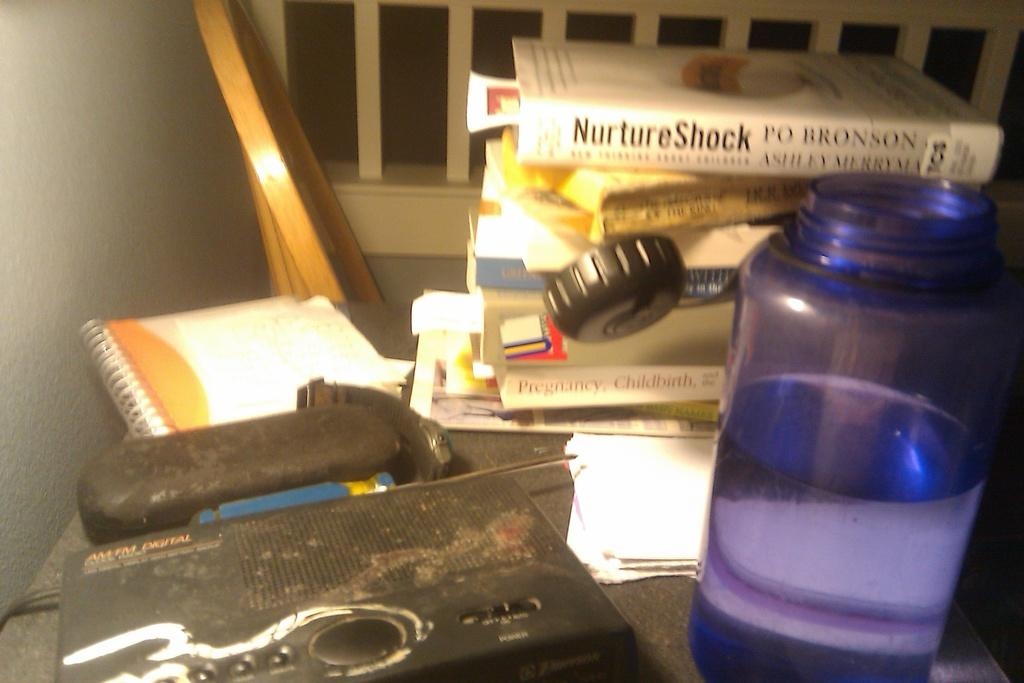<image>
Summarize the visual content of the image. the word nurture is on the white book 